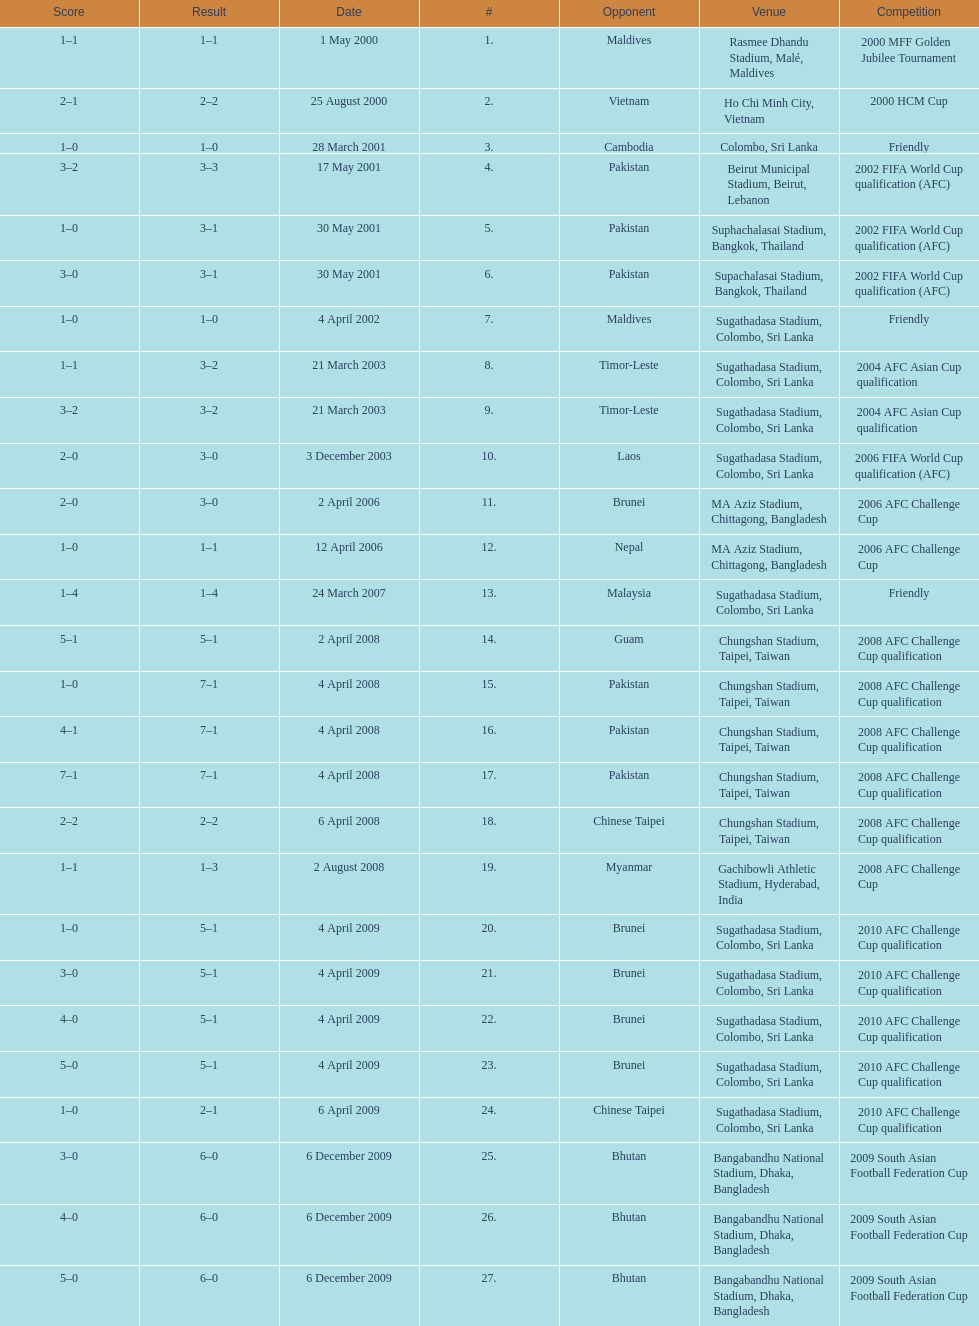Which venue has the largest result Chungshan Stadium, Taipei, Taiwan. 